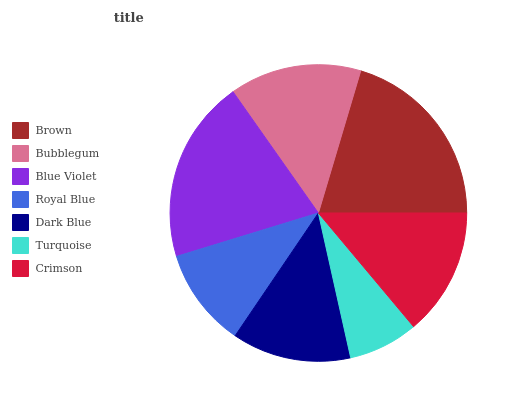Is Turquoise the minimum?
Answer yes or no. Yes. Is Brown the maximum?
Answer yes or no. Yes. Is Bubblegum the minimum?
Answer yes or no. No. Is Bubblegum the maximum?
Answer yes or no. No. Is Brown greater than Bubblegum?
Answer yes or no. Yes. Is Bubblegum less than Brown?
Answer yes or no. Yes. Is Bubblegum greater than Brown?
Answer yes or no. No. Is Brown less than Bubblegum?
Answer yes or no. No. Is Crimson the high median?
Answer yes or no. Yes. Is Crimson the low median?
Answer yes or no. Yes. Is Brown the high median?
Answer yes or no. No. Is Brown the low median?
Answer yes or no. No. 